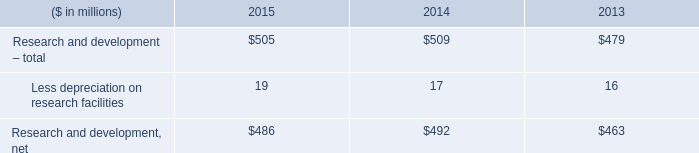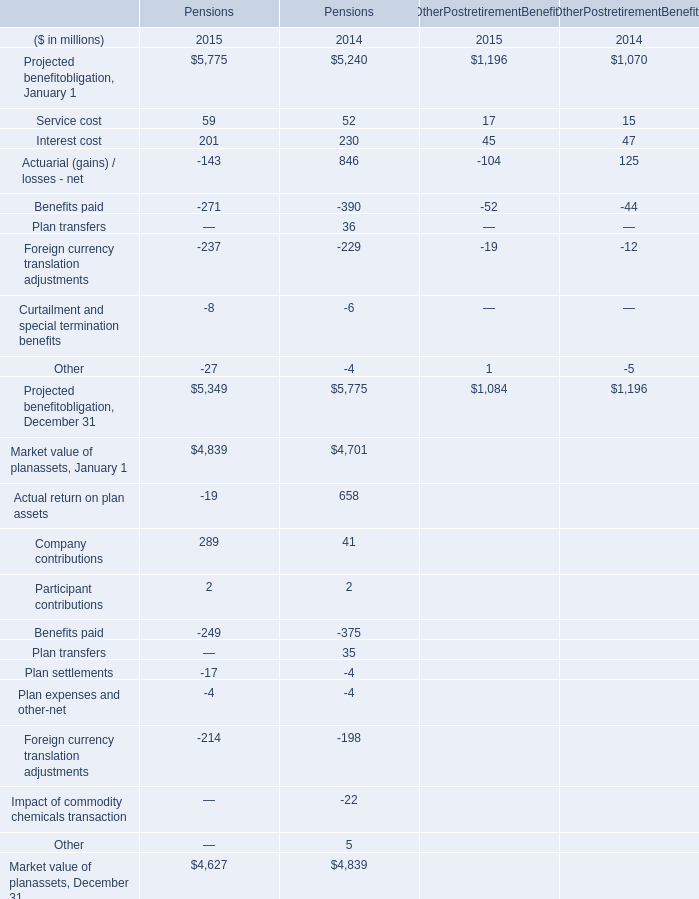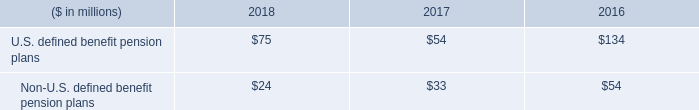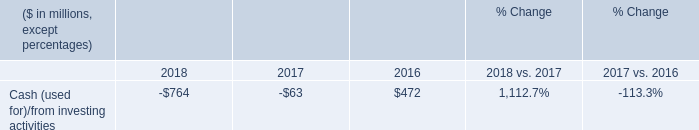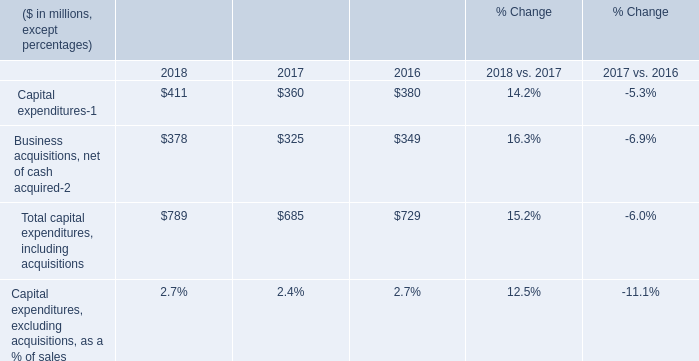What is the ratio of U.S. defined benefit pension plans in Table 2 to the Capital expenditures in Table 4 in 2016? 
Computations: (134 / 380)
Answer: 0.35263. 